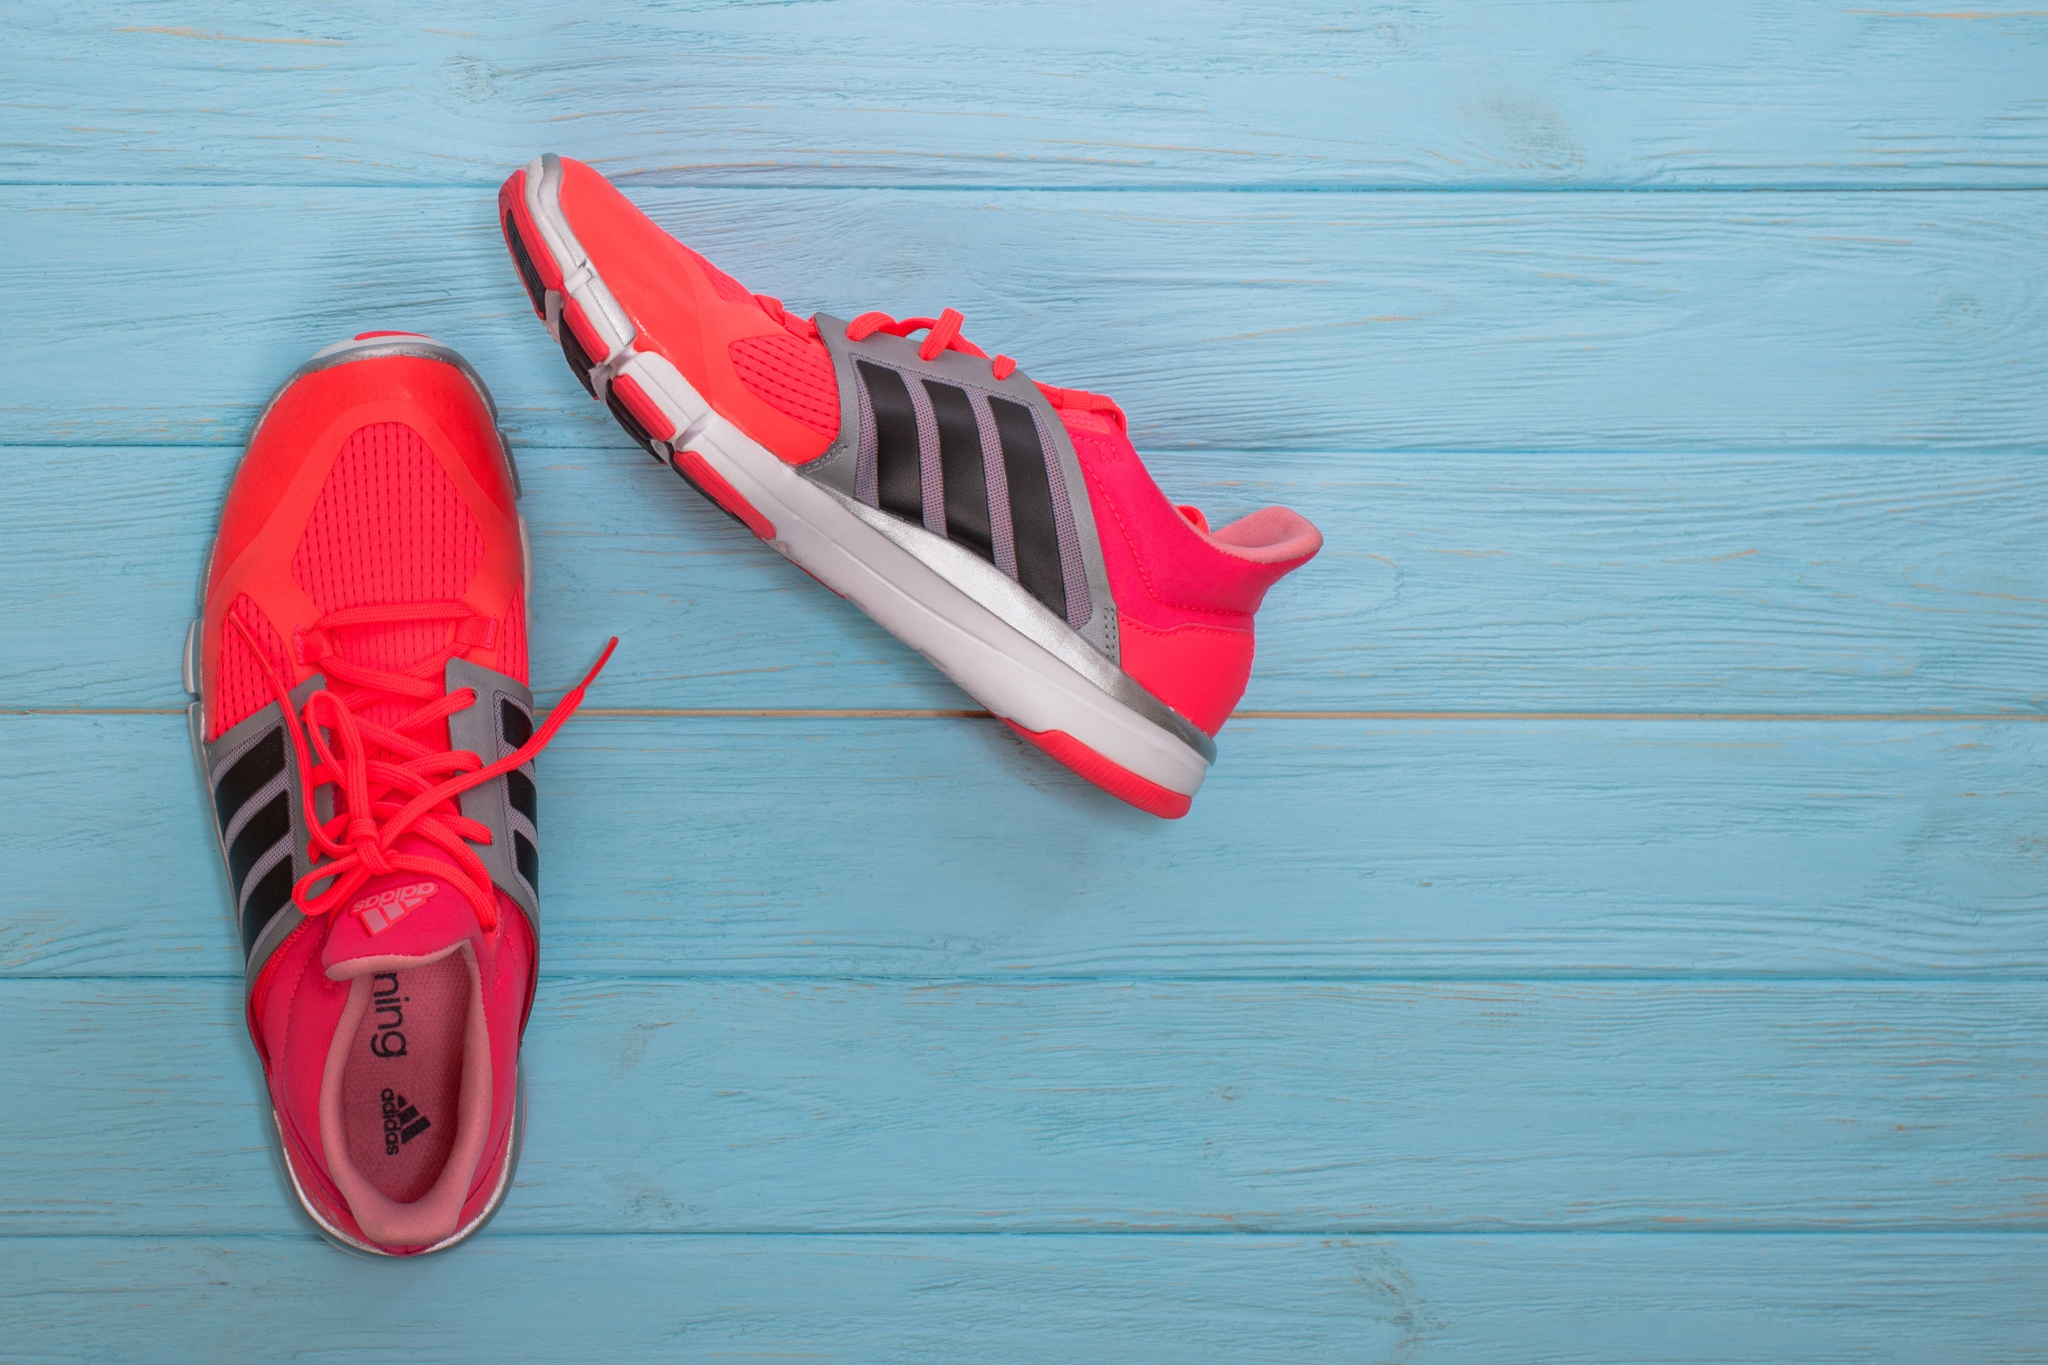Describe the color and design elements of the shoes. The shoes are predominantly a vivid red, exuding energy and vibrancy. They feature the classic black Adidas stripes along the sides, which provide a striking contrast against the red backdrop. The laces are also red, further enhancing the shoe's bold appearance. The soles have a touch of white, adding a subtle balance to the overall design. How does the background enhance the visual appeal of the image? The background consists of blue wooden planks with a weathered texture, which adds a rustic charm to the image. This blue hue contrasts beautifully with the vibrant red of the shoes, making them stand out prominently. The wood grain and slightly distressed look of the planks bring a depth and an organic element to the scene, making the bright and modern design of the shoes pop even more, creating an eye-catching visual appeal. If these shoes were part of an advertisement, what message do you think the ad would convey? The advertisement would likely convey a message of energy, vibrancy, and readiness for action. The bold red color suggests dynamism and confidence, while the sleek design and iconic Adidas stripes hint at quality and performance. The rustic wooden background might be used to juxtapose the cutting-edge design of the shoes, suggesting that no matter where you are or what environment you're in, these shoes are the perfect choice for your active lifestyle. The overall message might center around standing out, embracing your boldness, and being prepared to take on any challenge with style and confidence. Imagine a scenario where these shoes are found in an unexpected place. What story could unfold? In an abandoned, quaint countryside barn, rays of the early morning sun pierce through the slats of aged wood, illuminating a dusty, forgotten corner. There lies this striking pair of red Adidas running shoes, seemingly out of place in such a rustic setting. This visual anomaly piques the curiosity of an adventurous traveler who stumbles across the barn while on a morning run. Drawn by the juxtaposition, the traveler picks up the shoes, discovering a well-worn path outside the barn that leads to breathtaking, undiscovered trails. These shoes, left behind by a previous adventurer, now find a new path and purpose, symbolizing a bridge between past and present, connecting stories across time through shared journeys and experiences. 